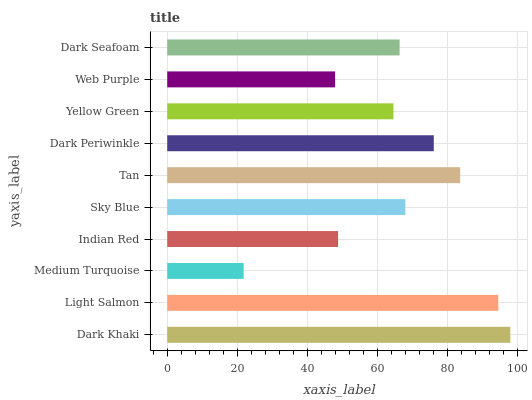Is Medium Turquoise the minimum?
Answer yes or no. Yes. Is Dark Khaki the maximum?
Answer yes or no. Yes. Is Light Salmon the minimum?
Answer yes or no. No. Is Light Salmon the maximum?
Answer yes or no. No. Is Dark Khaki greater than Light Salmon?
Answer yes or no. Yes. Is Light Salmon less than Dark Khaki?
Answer yes or no. Yes. Is Light Salmon greater than Dark Khaki?
Answer yes or no. No. Is Dark Khaki less than Light Salmon?
Answer yes or no. No. Is Sky Blue the high median?
Answer yes or no. Yes. Is Dark Seafoam the low median?
Answer yes or no. Yes. Is Indian Red the high median?
Answer yes or no. No. Is Web Purple the low median?
Answer yes or no. No. 